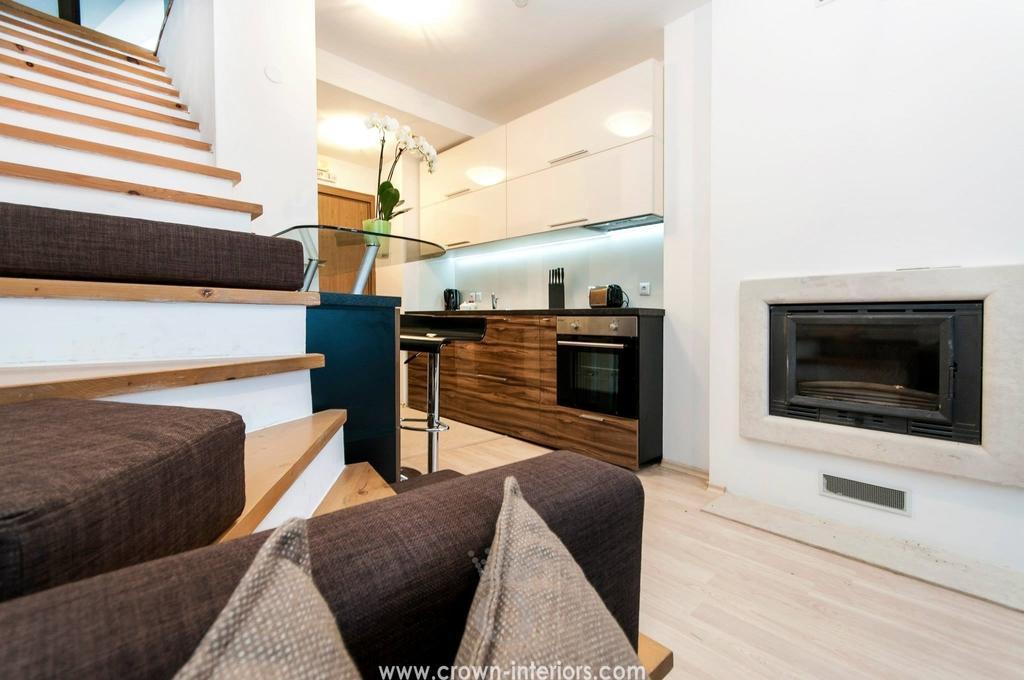Please provide a concise description of this image. On the left side there are steps, sofas and pillows. Near to that there is a table. On that there is a pot with flowers. In the back there is a platform with drawers. On that there are many items. On the wall there is a cupboard. On the ceiling there are lights. At the bottom there is a watermark. 